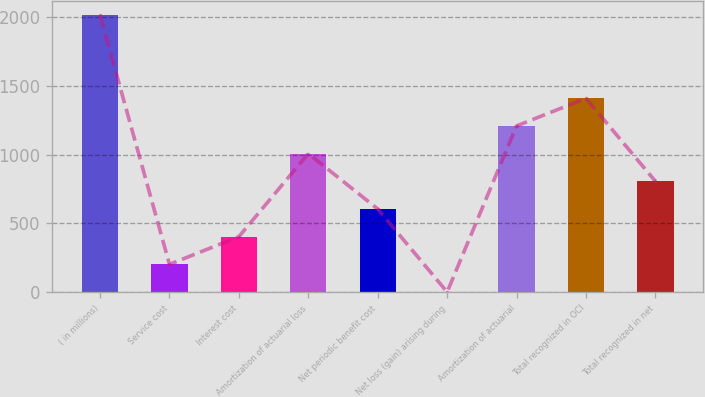Convert chart. <chart><loc_0><loc_0><loc_500><loc_500><bar_chart><fcel>( in millions)<fcel>Service cost<fcel>Interest cost<fcel>Amortization of actuarial loss<fcel>Net periodic benefit cost<fcel>Net loss (gain) arising during<fcel>Amortization of actuarial<fcel>Total recognized in OCI<fcel>Total recognized in net<nl><fcel>2014<fcel>201.49<fcel>402.88<fcel>1007.05<fcel>604.27<fcel>0.1<fcel>1208.44<fcel>1409.83<fcel>805.66<nl></chart> 